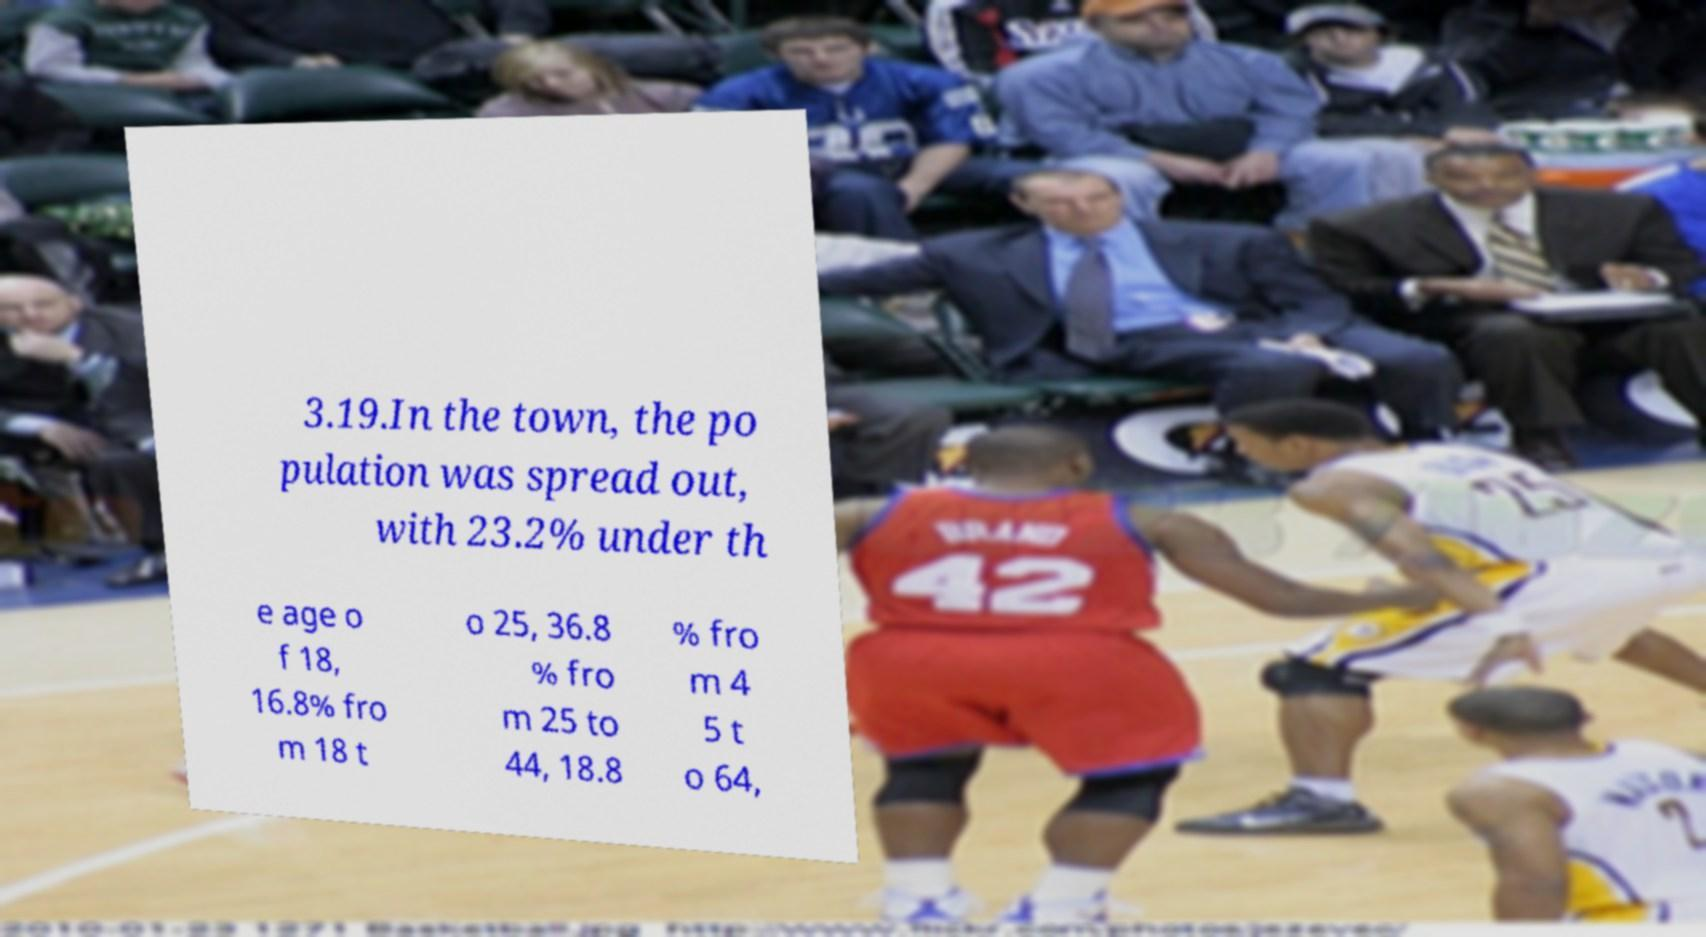Can you read and provide the text displayed in the image?This photo seems to have some interesting text. Can you extract and type it out for me? 3.19.In the town, the po pulation was spread out, with 23.2% under th e age o f 18, 16.8% fro m 18 t o 25, 36.8 % fro m 25 to 44, 18.8 % fro m 4 5 t o 64, 